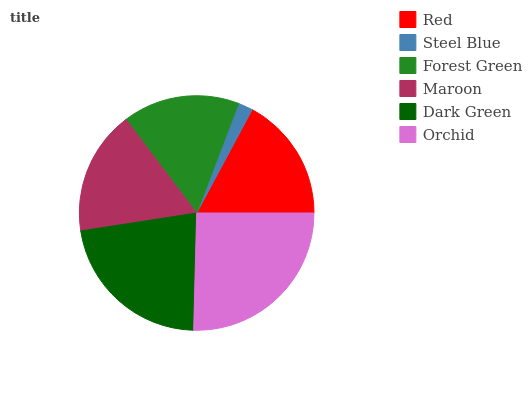Is Steel Blue the minimum?
Answer yes or no. Yes. Is Orchid the maximum?
Answer yes or no. Yes. Is Forest Green the minimum?
Answer yes or no. No. Is Forest Green the maximum?
Answer yes or no. No. Is Forest Green greater than Steel Blue?
Answer yes or no. Yes. Is Steel Blue less than Forest Green?
Answer yes or no. Yes. Is Steel Blue greater than Forest Green?
Answer yes or no. No. Is Forest Green less than Steel Blue?
Answer yes or no. No. Is Red the high median?
Answer yes or no. Yes. Is Maroon the low median?
Answer yes or no. Yes. Is Orchid the high median?
Answer yes or no. No. Is Red the low median?
Answer yes or no. No. 